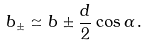<formula> <loc_0><loc_0><loc_500><loc_500>b _ { \pm } \simeq b \pm \frac { d } { 2 } \cos \alpha \, .</formula> 